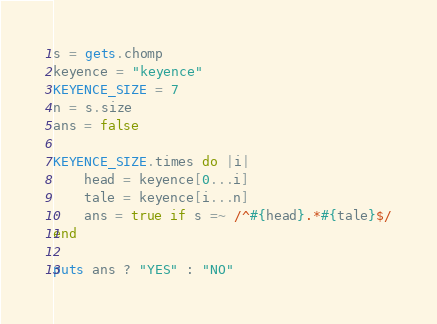Convert code to text. <code><loc_0><loc_0><loc_500><loc_500><_Ruby_>s = gets.chomp
keyence = "keyence"
KEYENCE_SIZE = 7
n = s.size
ans = false

KEYENCE_SIZE.times do |i|
    head = keyence[0...i]
    tale = keyence[i...n]
    ans = true if s =~ /^#{head}.*#{tale}$/
end

puts ans ? "YES" : "NO"</code> 